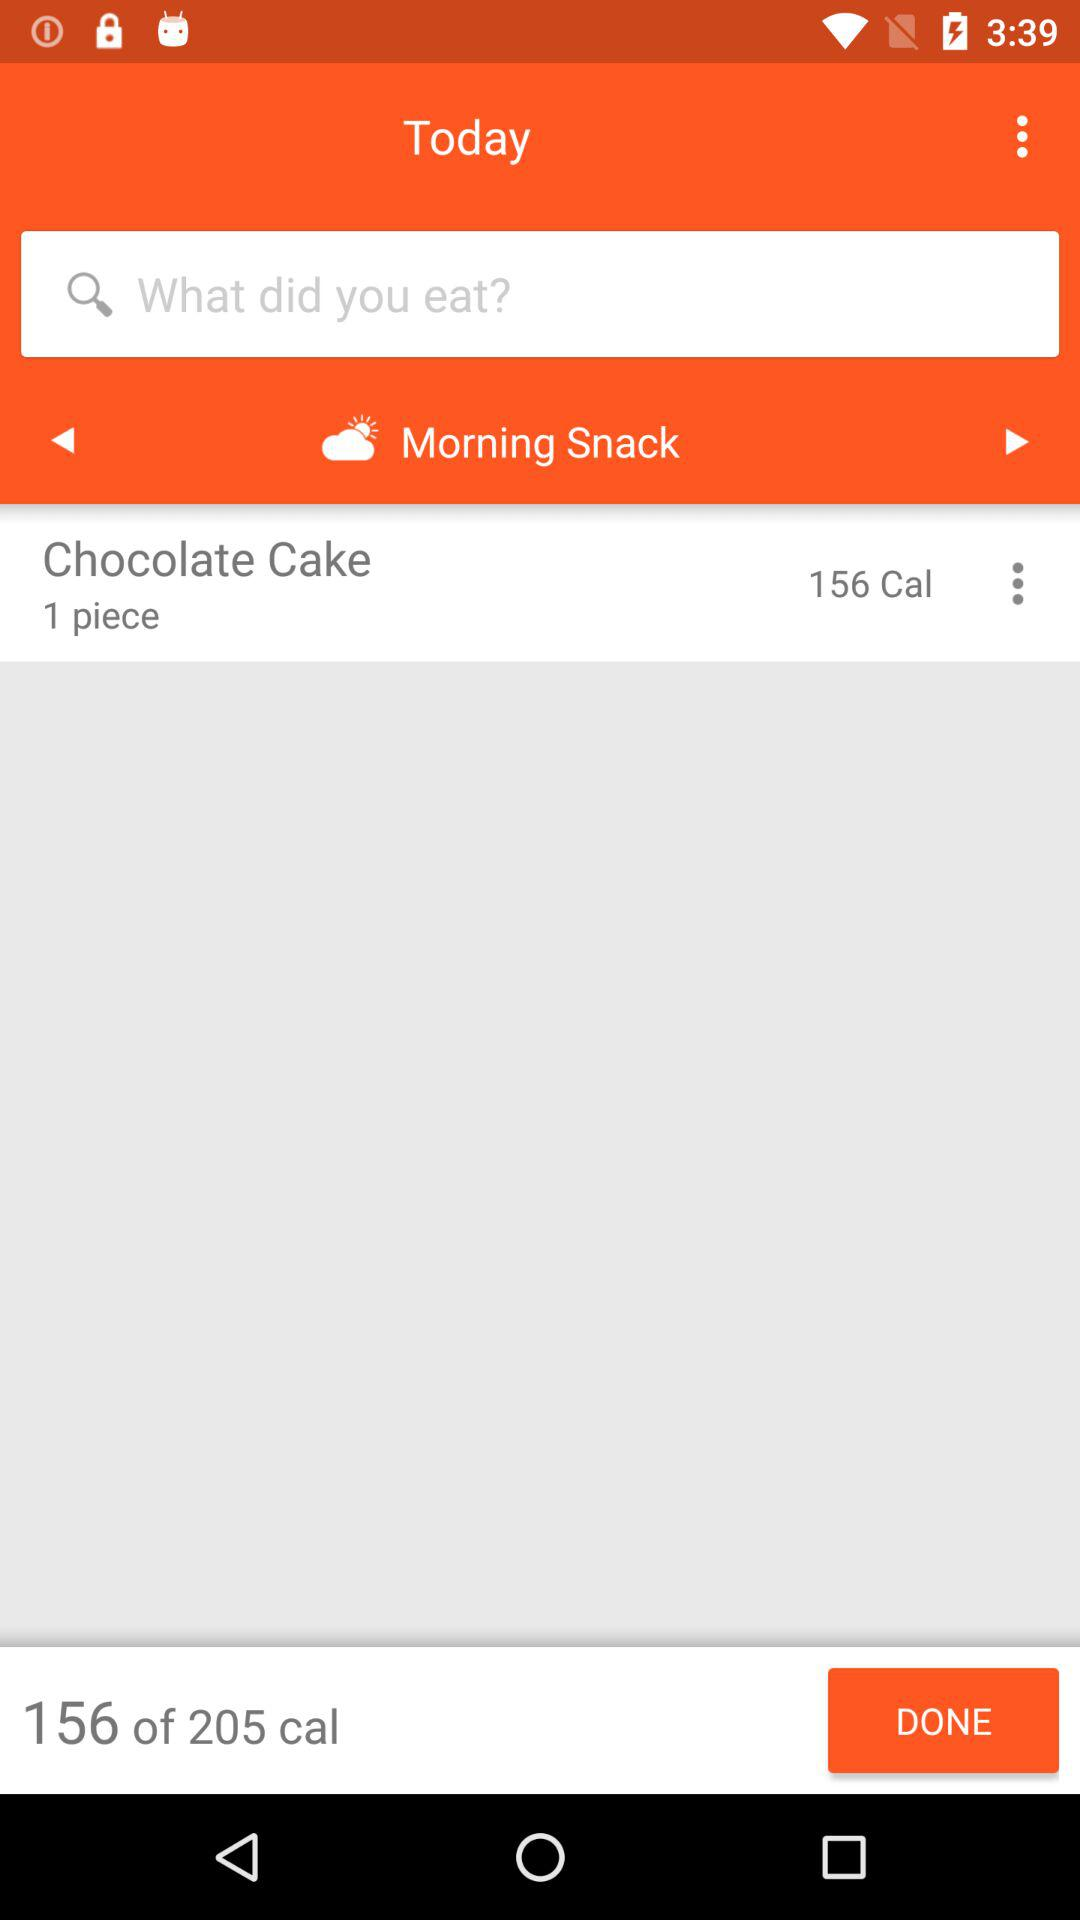What is the number of pieces of "Chocolate Cake"? The number of pieces of "Chocolate Cake" is 1. 